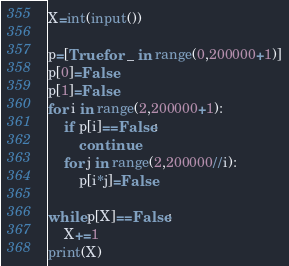Convert code to text. <code><loc_0><loc_0><loc_500><loc_500><_Python_>X=int(input())

p=[True for _ in range(0,200000+1)]
p[0]=False
p[1]=False
for i in range(2,200000+1):
    if p[i]==False:
        continue
    for j in range(2,200000//i):
        p[i*j]=False

while p[X]==False:
    X+=1
print(X)
</code> 